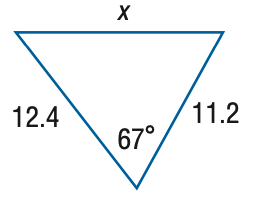Question: Find x. Round the side measure to the nearest tenth.
Choices:
A. 6.5
B. 13.1
C. 26.1
D. 52.3
Answer with the letter. Answer: B 